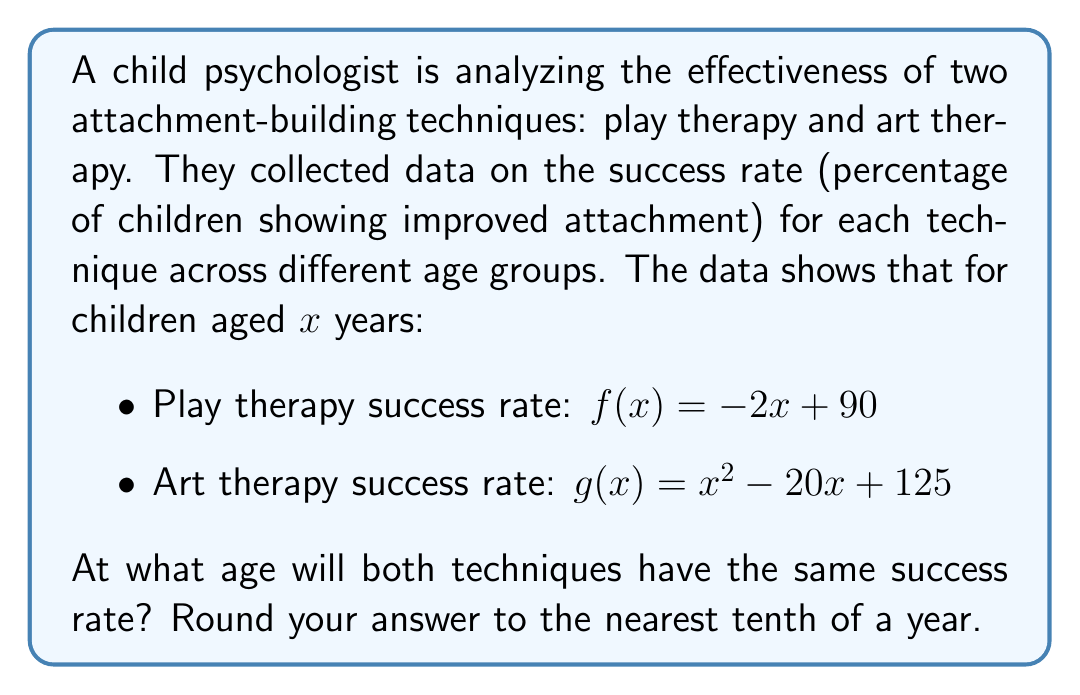Can you answer this question? To find the age at which both techniques have the same success rate, we need to solve the equation:

$$f(x) = g(x)$$

Substituting the given functions:

$$-2x + 90 = x^2 - 20x + 125$$

Rearranging the equation:

$$x^2 - 18x + 35 = 0$$

This is a quadratic equation in the form $ax^2 + bx + c = 0$, where:
$a = 1$, $b = -18$, and $c = 35$

We can solve this using the quadratic formula:

$$x = \frac{-b \pm \sqrt{b^2 - 4ac}}{2a}$$

Substituting the values:

$$x = \frac{18 \pm \sqrt{(-18)^2 - 4(1)(35)}}{2(1)}$$

$$x = \frac{18 \pm \sqrt{324 - 140}}{2}$$

$$x = \frac{18 \pm \sqrt{184}}{2}$$

$$x = \frac{18 \pm 13.56}{2}$$

This gives us two solutions:

$$x_1 = \frac{18 + 13.56}{2} = 15.78$$
$$x_2 = \frac{18 - 13.56}{2} = 2.22$$

Since age cannot be negative and we're dealing with children, the relevant solution is 15.78 years.

Rounding to the nearest tenth:

$$15.78 \approx 15.8 \text{ years}$$
Answer: 15.8 years 